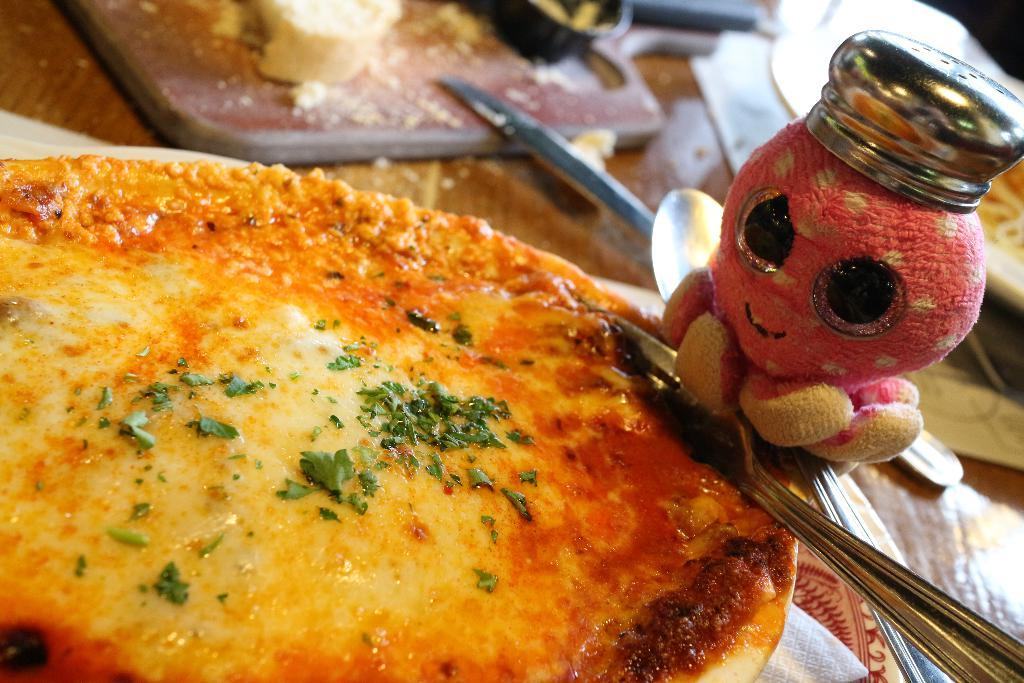What type of food is shown in the image? There is a pizza in the image. What utensil is present in the image? There is a spoon in the image. What other object can be seen in the image? There is a bottle in the image. How many basketballs are visible in the image? There are no basketballs present in the image. What type of attempt is being made in the image? There is no attempt being made in the image; it simply shows a pizza, a spoon, and a bottle. 